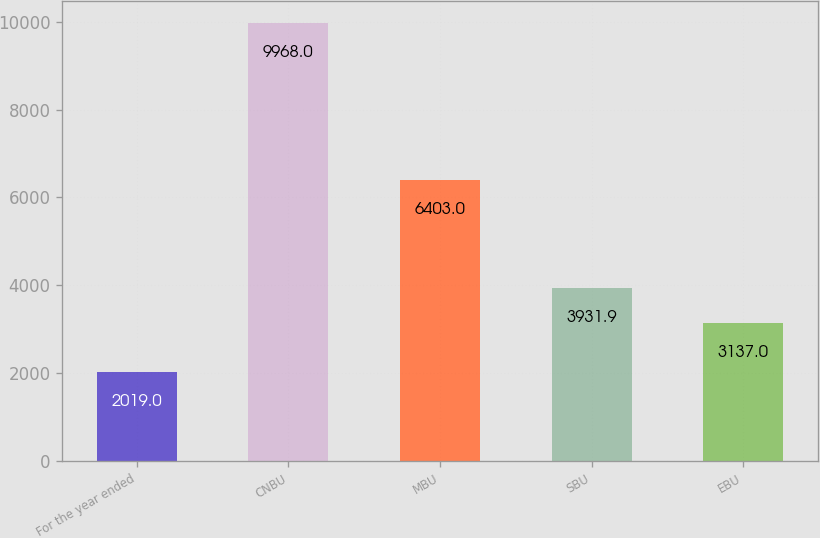Convert chart. <chart><loc_0><loc_0><loc_500><loc_500><bar_chart><fcel>For the year ended<fcel>CNBU<fcel>MBU<fcel>SBU<fcel>EBU<nl><fcel>2019<fcel>9968<fcel>6403<fcel>3931.9<fcel>3137<nl></chart> 